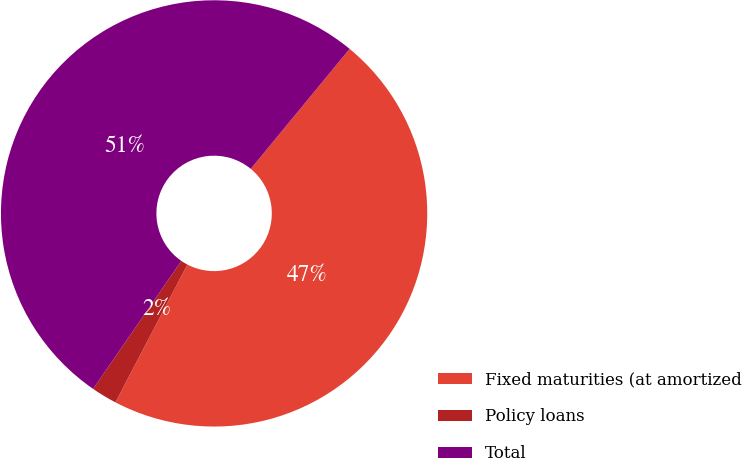<chart> <loc_0><loc_0><loc_500><loc_500><pie_chart><fcel>Fixed maturities (at amortized<fcel>Policy loans<fcel>Total<nl><fcel>46.69%<fcel>1.95%<fcel>51.36%<nl></chart> 